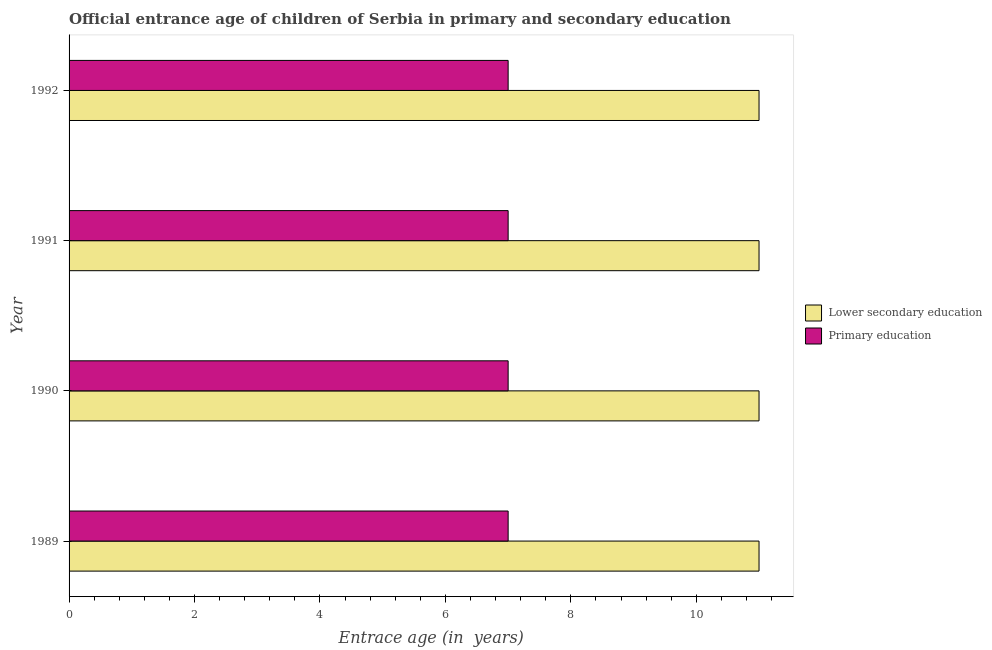How many groups of bars are there?
Offer a terse response. 4. Are the number of bars on each tick of the Y-axis equal?
Offer a terse response. Yes. What is the label of the 2nd group of bars from the top?
Give a very brief answer. 1991. What is the entrance age of chiildren in primary education in 1992?
Provide a short and direct response. 7. Across all years, what is the maximum entrance age of children in lower secondary education?
Ensure brevity in your answer.  11. Across all years, what is the minimum entrance age of children in lower secondary education?
Ensure brevity in your answer.  11. In which year was the entrance age of children in lower secondary education maximum?
Provide a succinct answer. 1989. In which year was the entrance age of children in lower secondary education minimum?
Offer a very short reply. 1989. What is the total entrance age of children in lower secondary education in the graph?
Offer a very short reply. 44. What is the difference between the entrance age of chiildren in primary education in 1989 and the entrance age of children in lower secondary education in 1991?
Ensure brevity in your answer.  -4. What is the average entrance age of children in lower secondary education per year?
Provide a succinct answer. 11. In the year 1989, what is the difference between the entrance age of chiildren in primary education and entrance age of children in lower secondary education?
Ensure brevity in your answer.  -4. What is the ratio of the entrance age of chiildren in primary education in 1991 to that in 1992?
Keep it short and to the point. 1. Is the difference between the entrance age of children in lower secondary education in 1990 and 1991 greater than the difference between the entrance age of chiildren in primary education in 1990 and 1991?
Offer a very short reply. No. What is the difference between the highest and the lowest entrance age of chiildren in primary education?
Your answer should be compact. 0. What does the 2nd bar from the top in 1992 represents?
Provide a short and direct response. Lower secondary education. What does the 1st bar from the bottom in 1992 represents?
Your response must be concise. Lower secondary education. Are all the bars in the graph horizontal?
Offer a terse response. Yes. How many years are there in the graph?
Your answer should be very brief. 4. Does the graph contain grids?
Make the answer very short. No. Where does the legend appear in the graph?
Your response must be concise. Center right. How many legend labels are there?
Your answer should be very brief. 2. What is the title of the graph?
Give a very brief answer. Official entrance age of children of Serbia in primary and secondary education. Does "Frequency of shipment arrival" appear as one of the legend labels in the graph?
Your answer should be compact. No. What is the label or title of the X-axis?
Give a very brief answer. Entrace age (in  years). What is the label or title of the Y-axis?
Your answer should be compact. Year. What is the Entrace age (in  years) in Lower secondary education in 1989?
Provide a short and direct response. 11. What is the Entrace age (in  years) of Lower secondary education in 1991?
Provide a succinct answer. 11. What is the Entrace age (in  years) of Lower secondary education in 1992?
Make the answer very short. 11. Across all years, what is the minimum Entrace age (in  years) of Lower secondary education?
Your answer should be compact. 11. Across all years, what is the minimum Entrace age (in  years) in Primary education?
Keep it short and to the point. 7. What is the total Entrace age (in  years) of Lower secondary education in the graph?
Keep it short and to the point. 44. What is the total Entrace age (in  years) in Primary education in the graph?
Provide a succinct answer. 28. What is the difference between the Entrace age (in  years) of Lower secondary education in 1989 and that in 1992?
Your answer should be compact. 0. What is the difference between the Entrace age (in  years) of Lower secondary education in 1990 and that in 1992?
Your answer should be compact. 0. What is the difference between the Entrace age (in  years) in Primary education in 1990 and that in 1992?
Provide a succinct answer. 0. What is the difference between the Entrace age (in  years) of Lower secondary education in 1989 and the Entrace age (in  years) of Primary education in 1990?
Your response must be concise. 4. What is the difference between the Entrace age (in  years) in Lower secondary education in 1989 and the Entrace age (in  years) in Primary education in 1991?
Offer a very short reply. 4. What is the difference between the Entrace age (in  years) of Lower secondary education in 1990 and the Entrace age (in  years) of Primary education in 1991?
Keep it short and to the point. 4. What is the difference between the Entrace age (in  years) of Lower secondary education in 1990 and the Entrace age (in  years) of Primary education in 1992?
Your answer should be compact. 4. In the year 1990, what is the difference between the Entrace age (in  years) in Lower secondary education and Entrace age (in  years) in Primary education?
Make the answer very short. 4. What is the ratio of the Entrace age (in  years) of Lower secondary education in 1989 to that in 1990?
Make the answer very short. 1. What is the ratio of the Entrace age (in  years) of Lower secondary education in 1989 to that in 1992?
Offer a very short reply. 1. What is the ratio of the Entrace age (in  years) in Lower secondary education in 1990 to that in 1991?
Keep it short and to the point. 1. What is the ratio of the Entrace age (in  years) in Primary education in 1990 to that in 1992?
Provide a succinct answer. 1. What is the ratio of the Entrace age (in  years) in Primary education in 1991 to that in 1992?
Keep it short and to the point. 1. What is the difference between the highest and the second highest Entrace age (in  years) in Lower secondary education?
Give a very brief answer. 0. What is the difference between the highest and the lowest Entrace age (in  years) in Lower secondary education?
Keep it short and to the point. 0. 